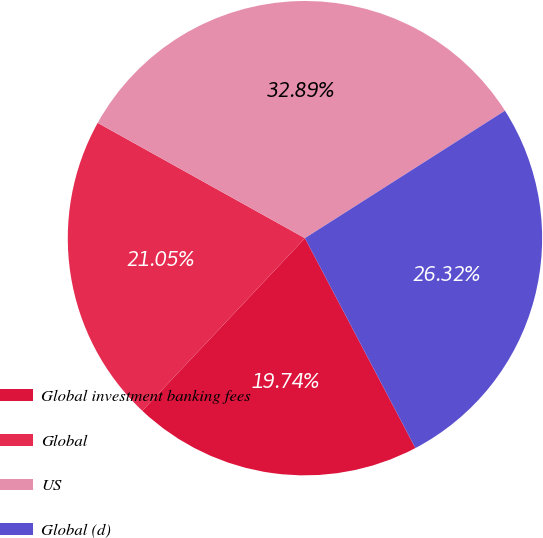<chart> <loc_0><loc_0><loc_500><loc_500><pie_chart><fcel>Global investment banking fees<fcel>Global<fcel>US<fcel>Global (d)<nl><fcel>19.74%<fcel>21.05%<fcel>32.89%<fcel>26.32%<nl></chart> 